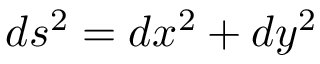Convert formula to latex. <formula><loc_0><loc_0><loc_500><loc_500>d s ^ { 2 } = d x ^ { 2 } + d y ^ { 2 }</formula> 